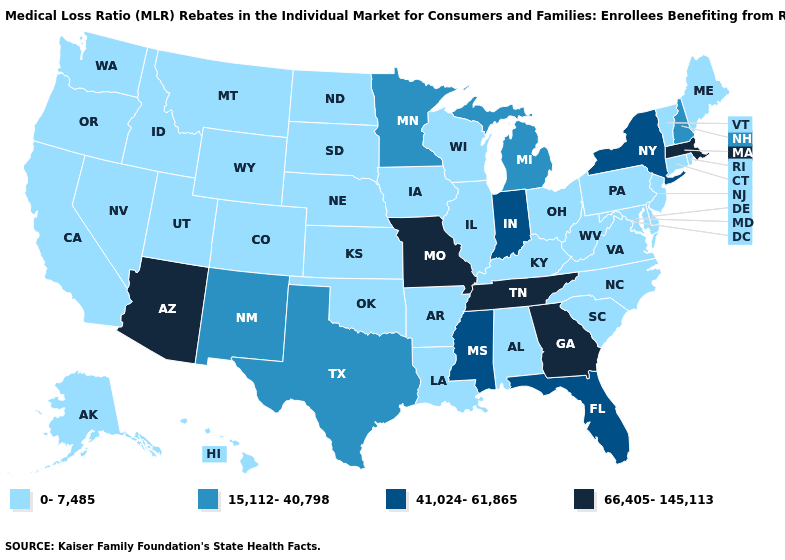Is the legend a continuous bar?
Short answer required. No. What is the value of Idaho?
Keep it brief. 0-7,485. Does New Mexico have a higher value than Washington?
Short answer required. Yes. Name the states that have a value in the range 0-7,485?
Short answer required. Alabama, Alaska, Arkansas, California, Colorado, Connecticut, Delaware, Hawaii, Idaho, Illinois, Iowa, Kansas, Kentucky, Louisiana, Maine, Maryland, Montana, Nebraska, Nevada, New Jersey, North Carolina, North Dakota, Ohio, Oklahoma, Oregon, Pennsylvania, Rhode Island, South Carolina, South Dakota, Utah, Vermont, Virginia, Washington, West Virginia, Wisconsin, Wyoming. Does California have the same value as Nebraska?
Give a very brief answer. Yes. What is the highest value in states that border Arkansas?
Short answer required. 66,405-145,113. Name the states that have a value in the range 15,112-40,798?
Write a very short answer. Michigan, Minnesota, New Hampshire, New Mexico, Texas. What is the highest value in the USA?
Answer briefly. 66,405-145,113. What is the lowest value in states that border Oregon?
Answer briefly. 0-7,485. Does the first symbol in the legend represent the smallest category?
Answer briefly. Yes. Does the first symbol in the legend represent the smallest category?
Be succinct. Yes. What is the value of New Mexico?
Short answer required. 15,112-40,798. Name the states that have a value in the range 0-7,485?
Concise answer only. Alabama, Alaska, Arkansas, California, Colorado, Connecticut, Delaware, Hawaii, Idaho, Illinois, Iowa, Kansas, Kentucky, Louisiana, Maine, Maryland, Montana, Nebraska, Nevada, New Jersey, North Carolina, North Dakota, Ohio, Oklahoma, Oregon, Pennsylvania, Rhode Island, South Carolina, South Dakota, Utah, Vermont, Virginia, Washington, West Virginia, Wisconsin, Wyoming. Does the first symbol in the legend represent the smallest category?
Quick response, please. Yes. 